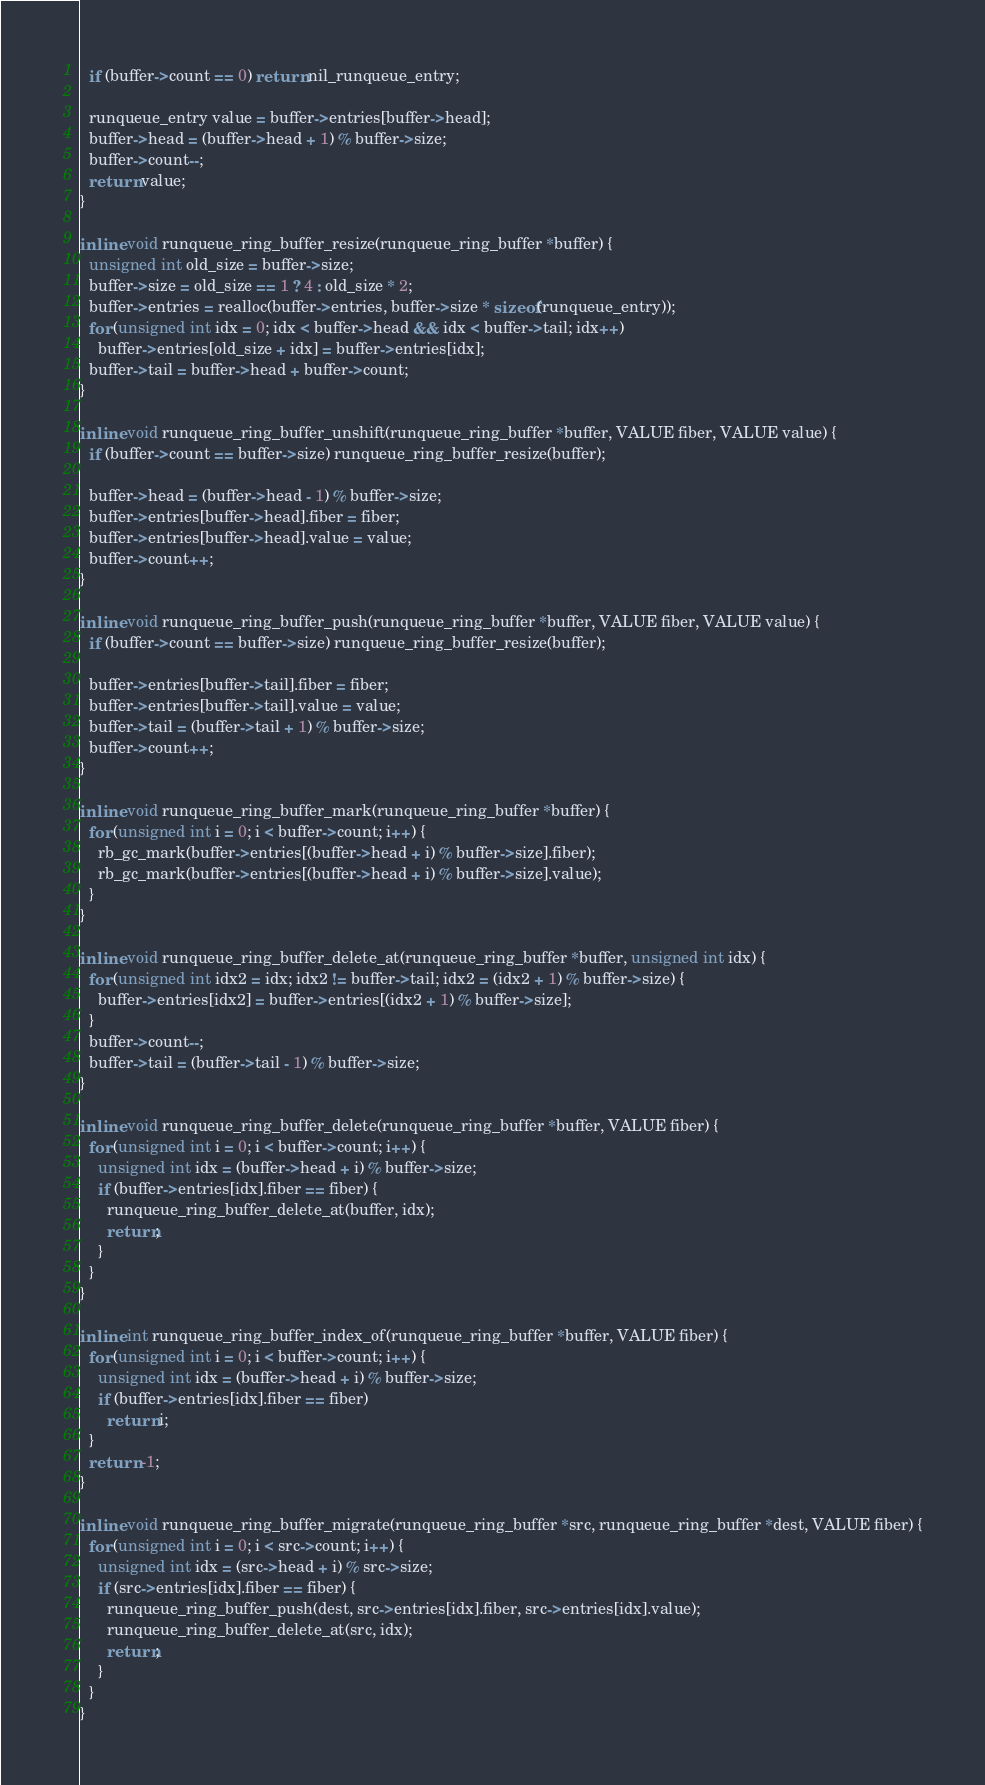<code> <loc_0><loc_0><loc_500><loc_500><_C_>  if (buffer->count == 0) return nil_runqueue_entry;

  runqueue_entry value = buffer->entries[buffer->head];
  buffer->head = (buffer->head + 1) % buffer->size;
  buffer->count--;
  return value;
}

inline void runqueue_ring_buffer_resize(runqueue_ring_buffer *buffer) {
  unsigned int old_size = buffer->size;
  buffer->size = old_size == 1 ? 4 : old_size * 2;
  buffer->entries = realloc(buffer->entries, buffer->size * sizeof(runqueue_entry));
  for (unsigned int idx = 0; idx < buffer->head && idx < buffer->tail; idx++)
    buffer->entries[old_size + idx] = buffer->entries[idx];
  buffer->tail = buffer->head + buffer->count;
}

inline void runqueue_ring_buffer_unshift(runqueue_ring_buffer *buffer, VALUE fiber, VALUE value) {
  if (buffer->count == buffer->size) runqueue_ring_buffer_resize(buffer);

  buffer->head = (buffer->head - 1) % buffer->size;
  buffer->entries[buffer->head].fiber = fiber;
  buffer->entries[buffer->head].value = value;
  buffer->count++;
}

inline void runqueue_ring_buffer_push(runqueue_ring_buffer *buffer, VALUE fiber, VALUE value) {
  if (buffer->count == buffer->size) runqueue_ring_buffer_resize(buffer);

  buffer->entries[buffer->tail].fiber = fiber;
  buffer->entries[buffer->tail].value = value;
  buffer->tail = (buffer->tail + 1) % buffer->size;
  buffer->count++;
}

inline void runqueue_ring_buffer_mark(runqueue_ring_buffer *buffer) {
  for (unsigned int i = 0; i < buffer->count; i++) {
    rb_gc_mark(buffer->entries[(buffer->head + i) % buffer->size].fiber);
    rb_gc_mark(buffer->entries[(buffer->head + i) % buffer->size].value);
  }
}

inline void runqueue_ring_buffer_delete_at(runqueue_ring_buffer *buffer, unsigned int idx) {
  for (unsigned int idx2 = idx; idx2 != buffer->tail; idx2 = (idx2 + 1) % buffer->size) {
    buffer->entries[idx2] = buffer->entries[(idx2 + 1) % buffer->size];
  }
  buffer->count--;
  buffer->tail = (buffer->tail - 1) % buffer->size;
}

inline void runqueue_ring_buffer_delete(runqueue_ring_buffer *buffer, VALUE fiber) {
  for (unsigned int i = 0; i < buffer->count; i++) {
    unsigned int idx = (buffer->head + i) % buffer->size;
    if (buffer->entries[idx].fiber == fiber) {
      runqueue_ring_buffer_delete_at(buffer, idx);
      return;
    }
  }
}

inline int runqueue_ring_buffer_index_of(runqueue_ring_buffer *buffer, VALUE fiber) {
  for (unsigned int i = 0; i < buffer->count; i++) {
    unsigned int idx = (buffer->head + i) % buffer->size;
    if (buffer->entries[idx].fiber == fiber)
      return i;
  }
  return -1;
}

inline void runqueue_ring_buffer_migrate(runqueue_ring_buffer *src, runqueue_ring_buffer *dest, VALUE fiber) {
  for (unsigned int i = 0; i < src->count; i++) {
    unsigned int idx = (src->head + i) % src->size;
    if (src->entries[idx].fiber == fiber) {
      runqueue_ring_buffer_push(dest, src->entries[idx].fiber, src->entries[idx].value);
      runqueue_ring_buffer_delete_at(src, idx);
      return;
    }
  }
}
</code> 